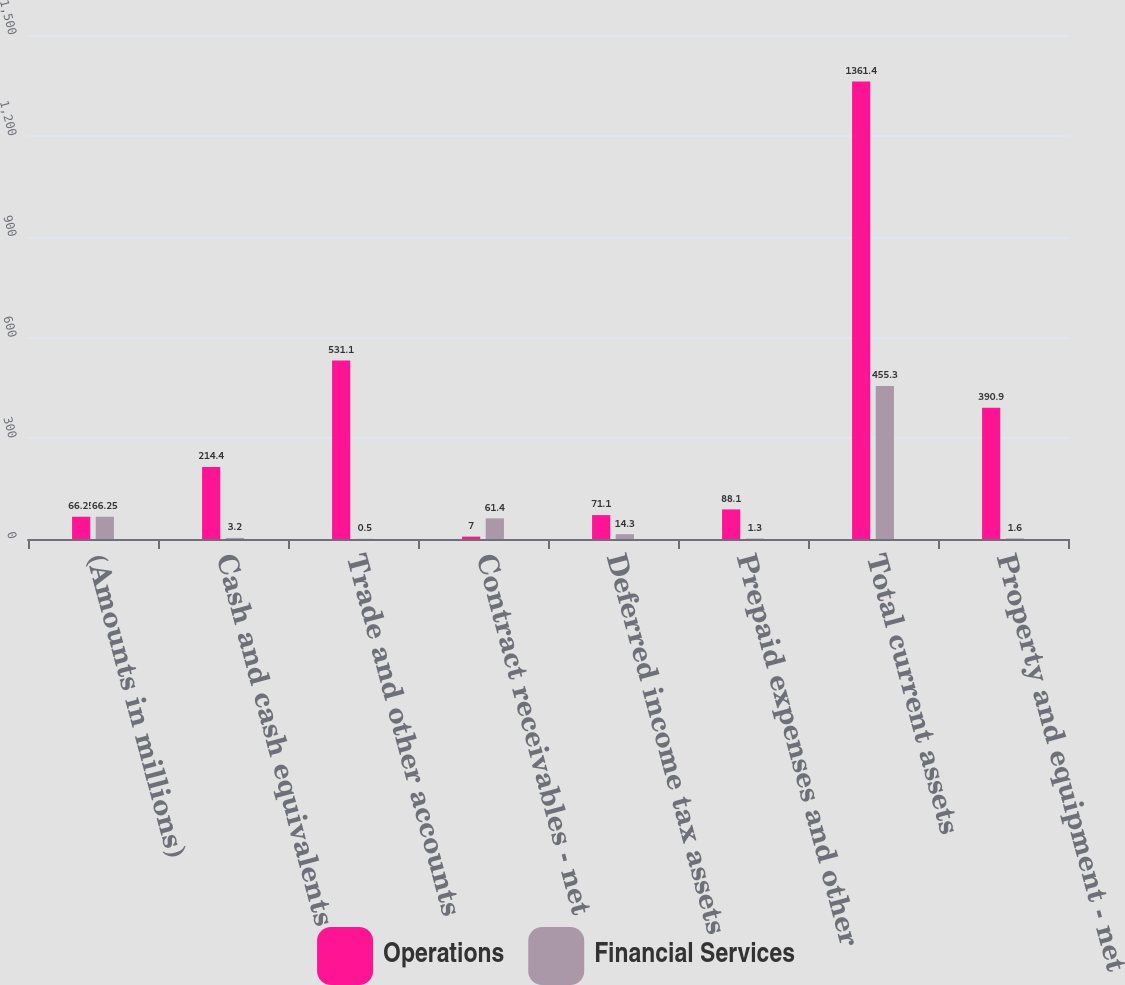<chart> <loc_0><loc_0><loc_500><loc_500><stacked_bar_chart><ecel><fcel>(Amounts in millions)<fcel>Cash and cash equivalents<fcel>Trade and other accounts<fcel>Contract receivables - net<fcel>Deferred income tax assets<fcel>Prepaid expenses and other<fcel>Total current assets<fcel>Property and equipment - net<nl><fcel>Operations<fcel>66.25<fcel>214.4<fcel>531.1<fcel>7<fcel>71.1<fcel>88.1<fcel>1361.4<fcel>390.9<nl><fcel>Financial Services<fcel>66.25<fcel>3.2<fcel>0.5<fcel>61.4<fcel>14.3<fcel>1.3<fcel>455.3<fcel>1.6<nl></chart> 